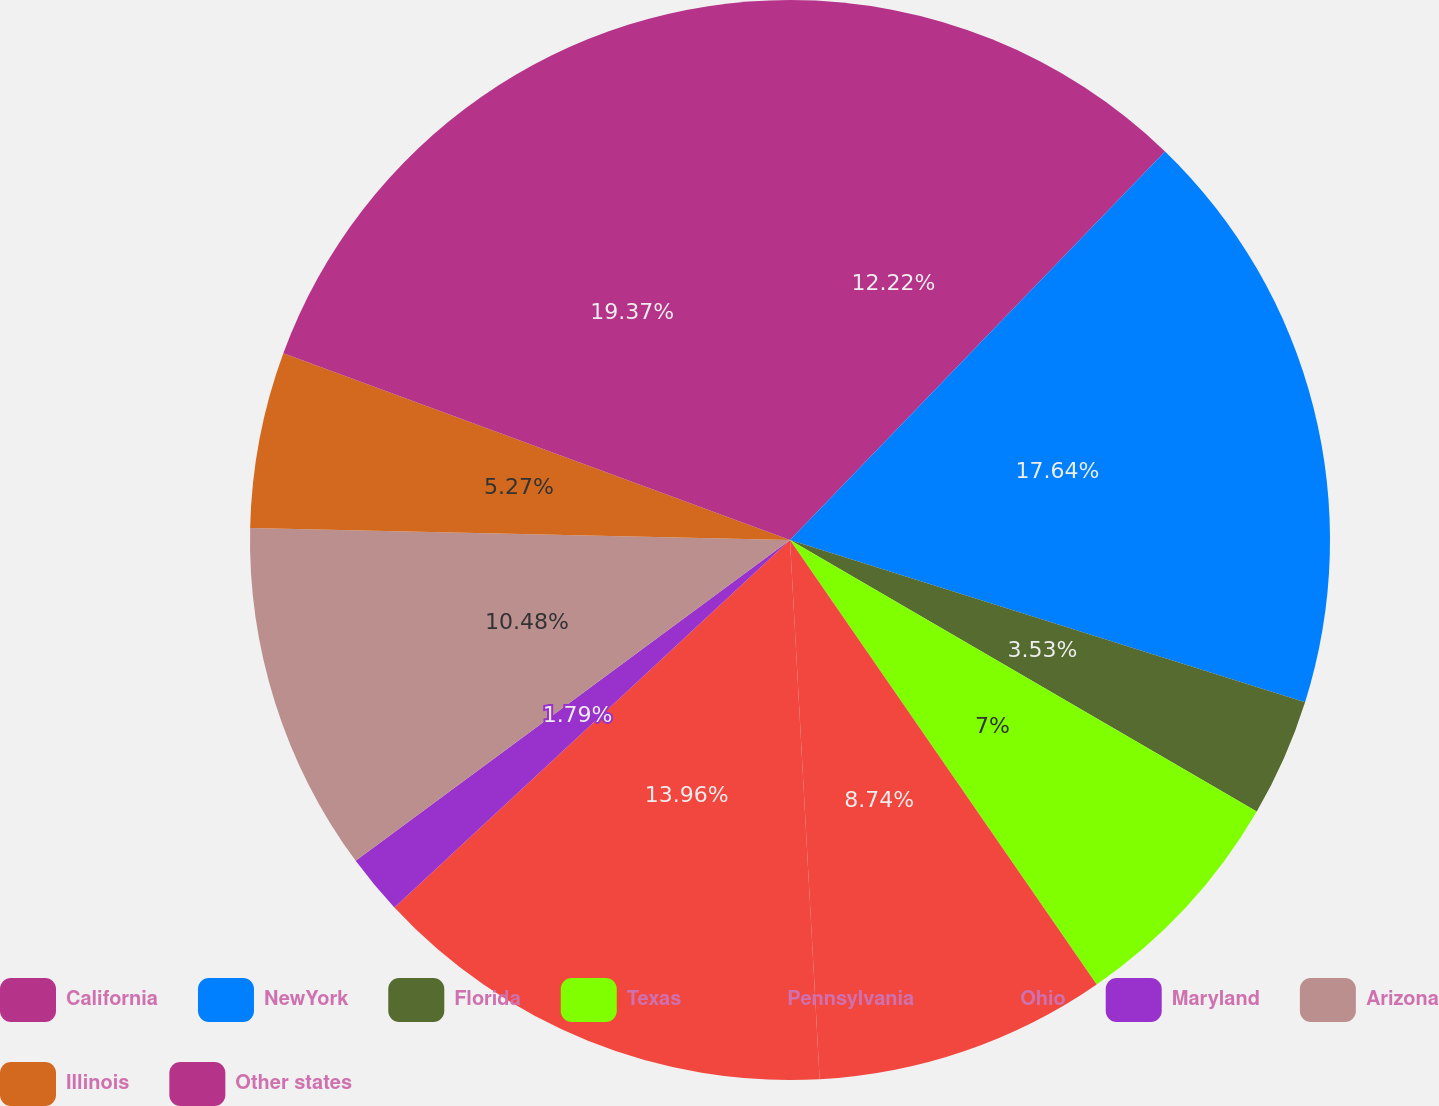Convert chart. <chart><loc_0><loc_0><loc_500><loc_500><pie_chart><fcel>California<fcel>NewYork<fcel>Florida<fcel>Texas<fcel>Pennsylvania<fcel>Ohio<fcel>Maryland<fcel>Arizona<fcel>Illinois<fcel>Other states<nl><fcel>12.22%<fcel>17.64%<fcel>3.53%<fcel>7.0%<fcel>8.74%<fcel>13.96%<fcel>1.79%<fcel>10.48%<fcel>5.27%<fcel>19.38%<nl></chart> 